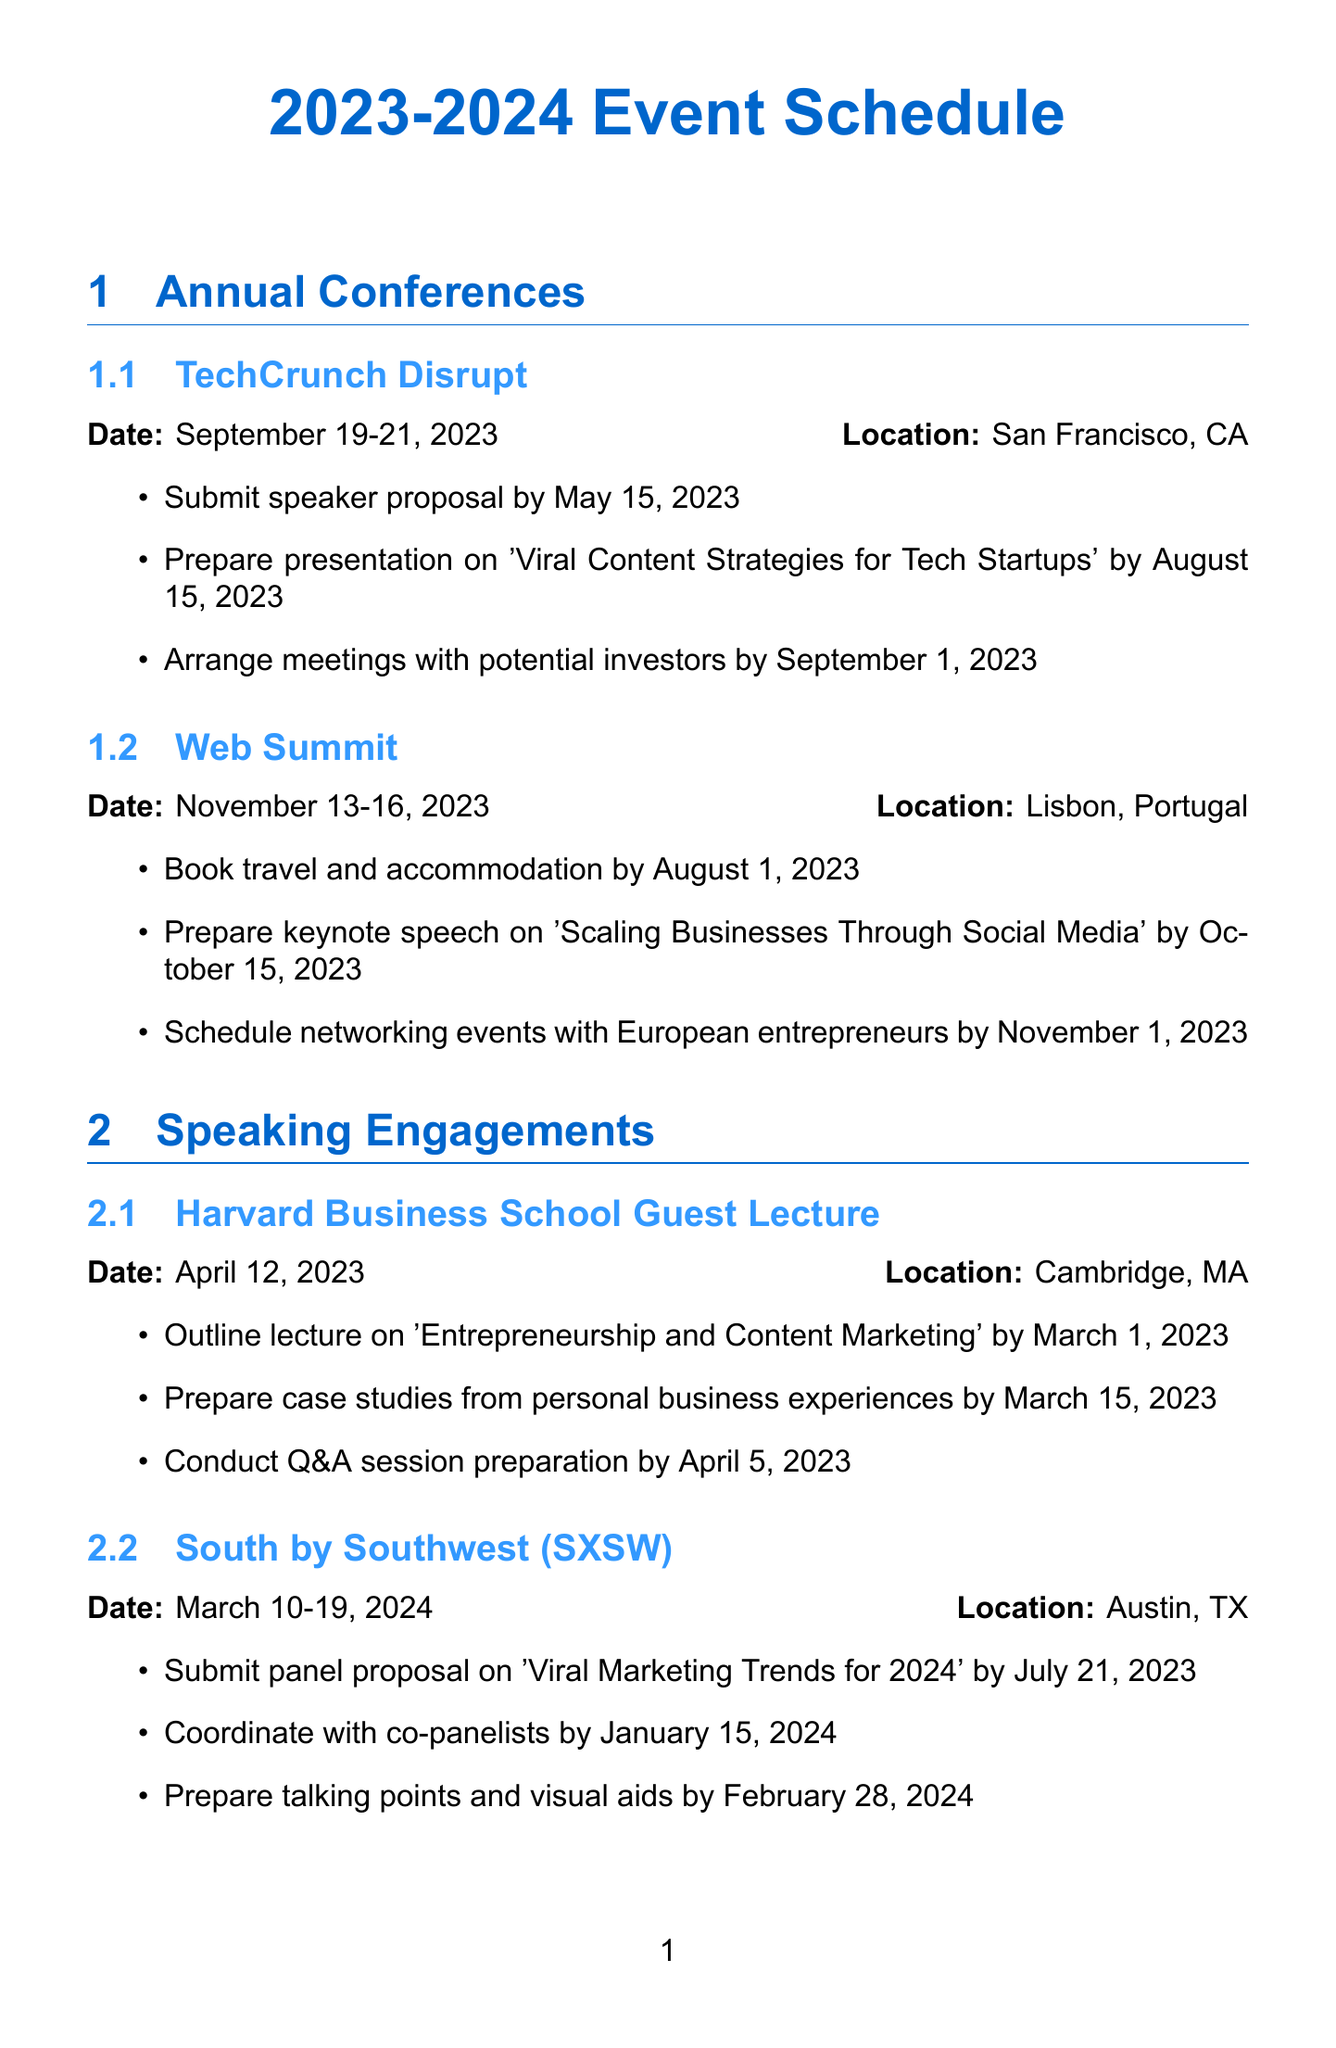What is the date of TechCrunch Disrupt? The date for TechCrunch Disrupt is listed in the document as September 19-21, 2023.
Answer: September 19-21, 2023 Where is the Web Summit located? The document specifies that the location of the Web Summit is Lisbon, Portugal.
Answer: Lisbon, Portugal When is the deadline to prepare the keynote speech for Web Summit? The deadline for preparing the keynote speech is indicated as October 15, 2023, in the preparation timeline for the Web Summit.
Answer: October 15, 2023 How many tasks are there to prepare for the South by Southwest (SXSW) event? By counting the items in the preparation timeline for SXSW, there are three tasks listed.
Answer: 3 What is the title of the presentation for TechCrunch Disrupt? The document reveals the presentation title for TechCrunch Disrupt as 'Viral Content Strategies for Tech Startups'.
Answer: Viral Content Strategies for Tech Startups What is the location of the Harvard Business School Guest Lecture? The location provided for the Harvard Business School Guest Lecture is Cambridge, MA.
Answer: Cambridge, MA What is the first task to prepare for the VidCon event? The initial task listed for VidCon preparation is to prepare a workshop on 'Creating Viral Video Content for Businesses'.
Answer: Prepare workshop on 'Creating Viral Video Content for Businesses' What is the deadline for submitting a proposal for the Content Marketing World event? The deadline for the proposal submission, as stated in the document, is April 30, 2023.
Answer: April 30, 2023 Which event requires an invitation and registration by October 1, 2023? According to the document, the World Economic Forum Annual Meeting requires an invitation and registration by that date.
Answer: World Economic Forum Annual Meeting 